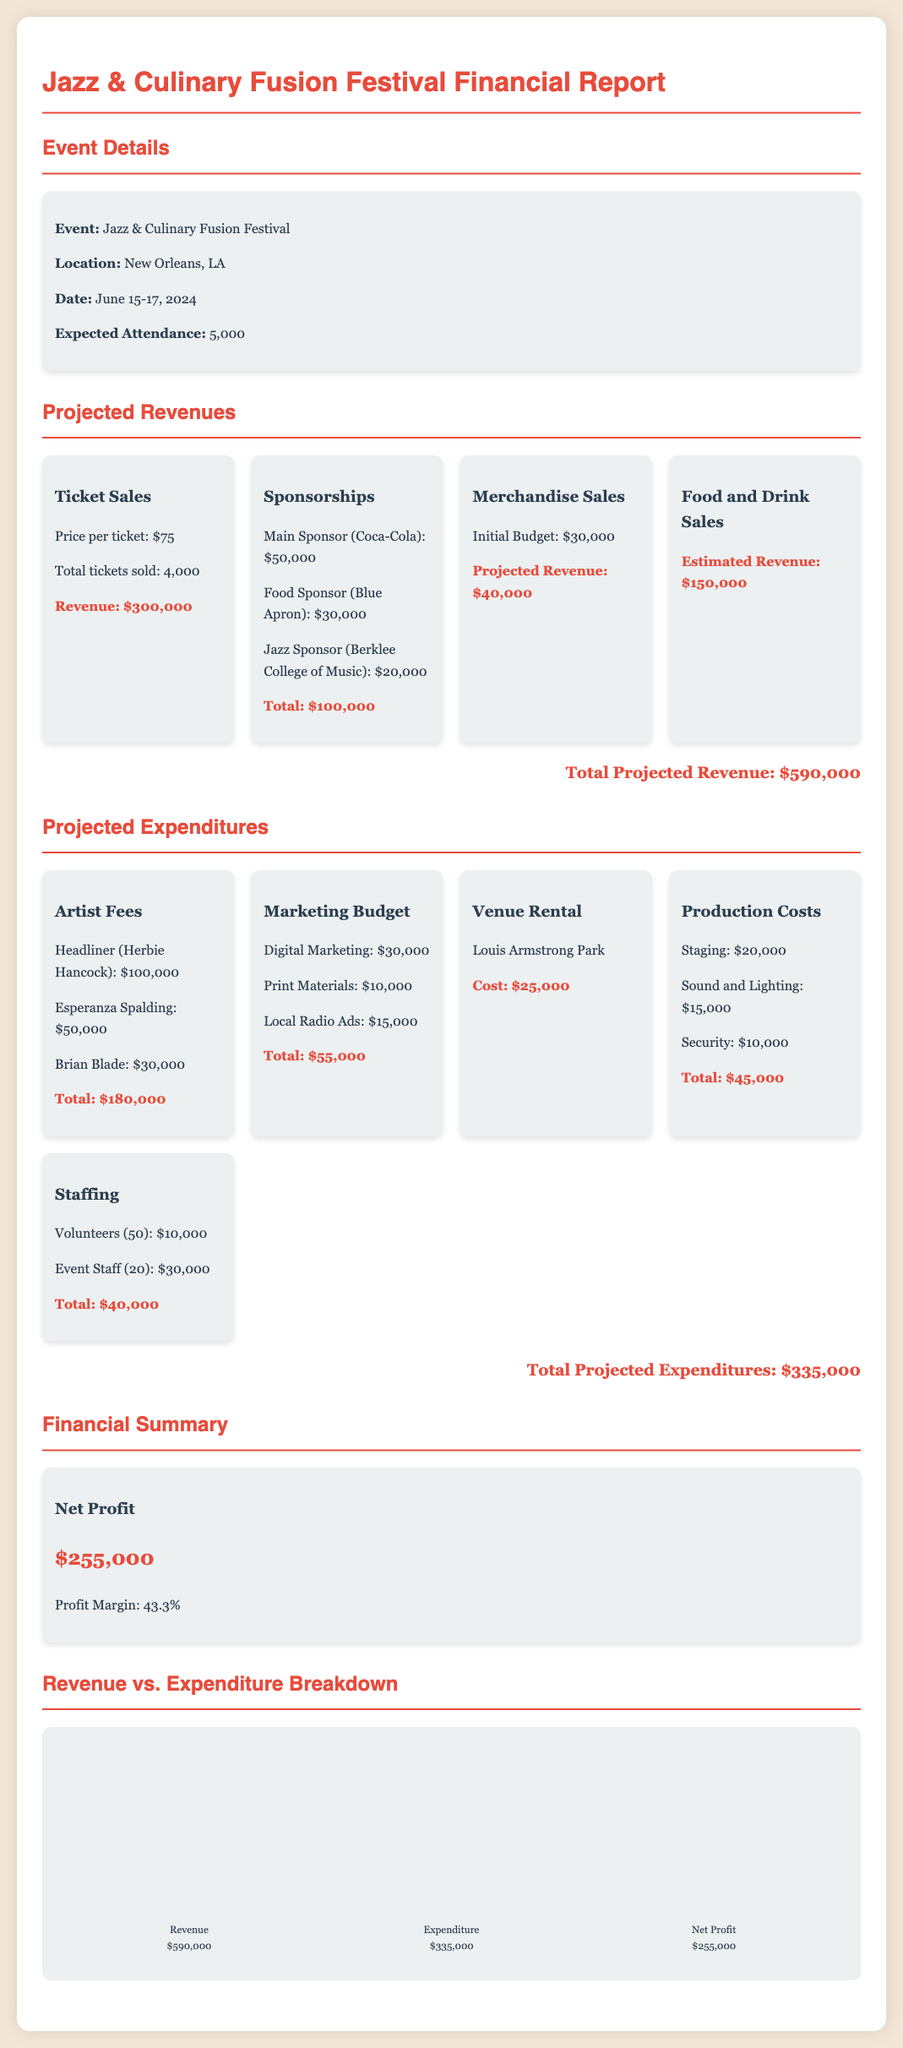What is the event name? The event name is clearly stated in the document as "Jazz & Culinary Fusion Festival."
Answer: Jazz & Culinary Fusion Festival What is the location of the festival? The document specifies that the festival will be held in New Orleans, LA.
Answer: New Orleans, LA What is the expected attendance for the event? The expected attendance figure is mentioned in the event details section, which states 5,000 attendees.
Answer: 5,000 What is the total projected revenue? The total projected revenue is calculated by summing all revenue categories, which amounts to $590,000.
Answer: $590,000 What are the artist fees for Herbie Hancock? The fee for the headliner, Herbie Hancock, is listed as $100,000.
Answer: $100,000 How much is allocated for the marketing budget? The total for the marketing budget, which includes various marketing efforts, is $55,000.
Answer: $55,000 What is the estimated revenue from food and drink sales? The estimated revenue from food and drink sales is highlighted in the document as $150,000.
Answer: $150,000 What is the net profit for the festival? The net profit is clearly stated as $255,000, which is calculated from revenues and expenditures.
Answer: $255,000 What percentage is the profit margin? The profit margin is provided in the financial summary as 43.3%.
Answer: 43.3% 